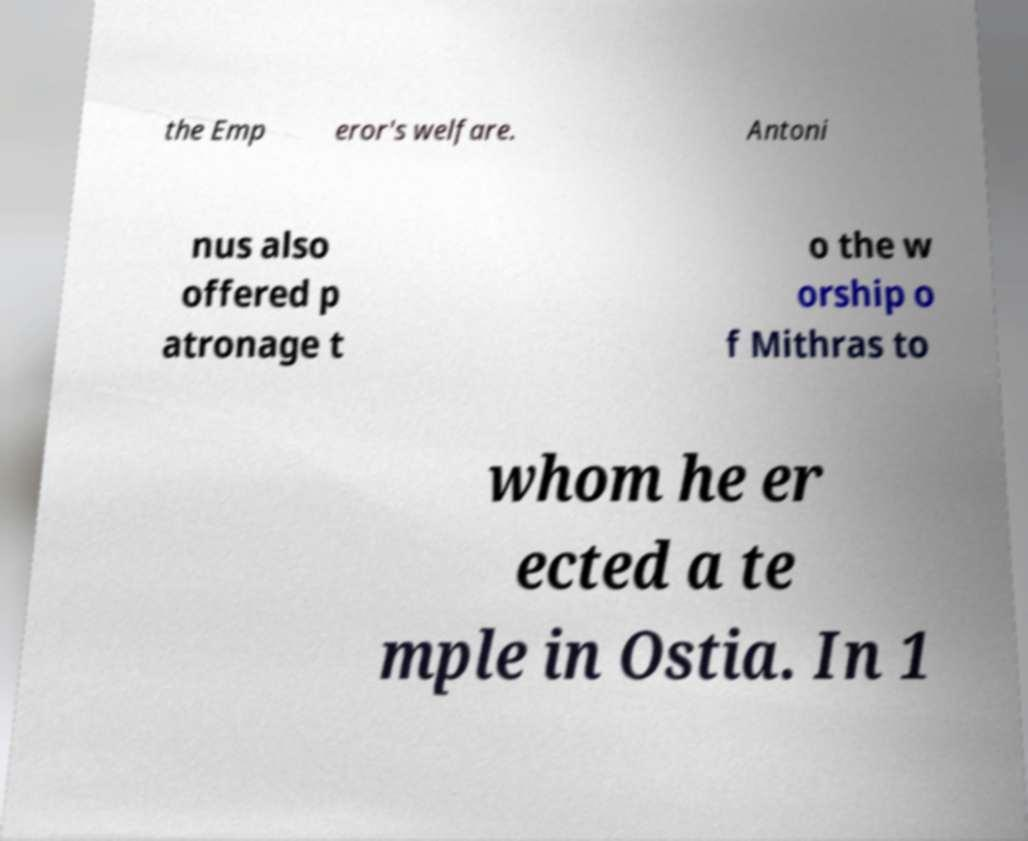What messages or text are displayed in this image? I need them in a readable, typed format. the Emp eror's welfare. Antoni nus also offered p atronage t o the w orship o f Mithras to whom he er ected a te mple in Ostia. In 1 